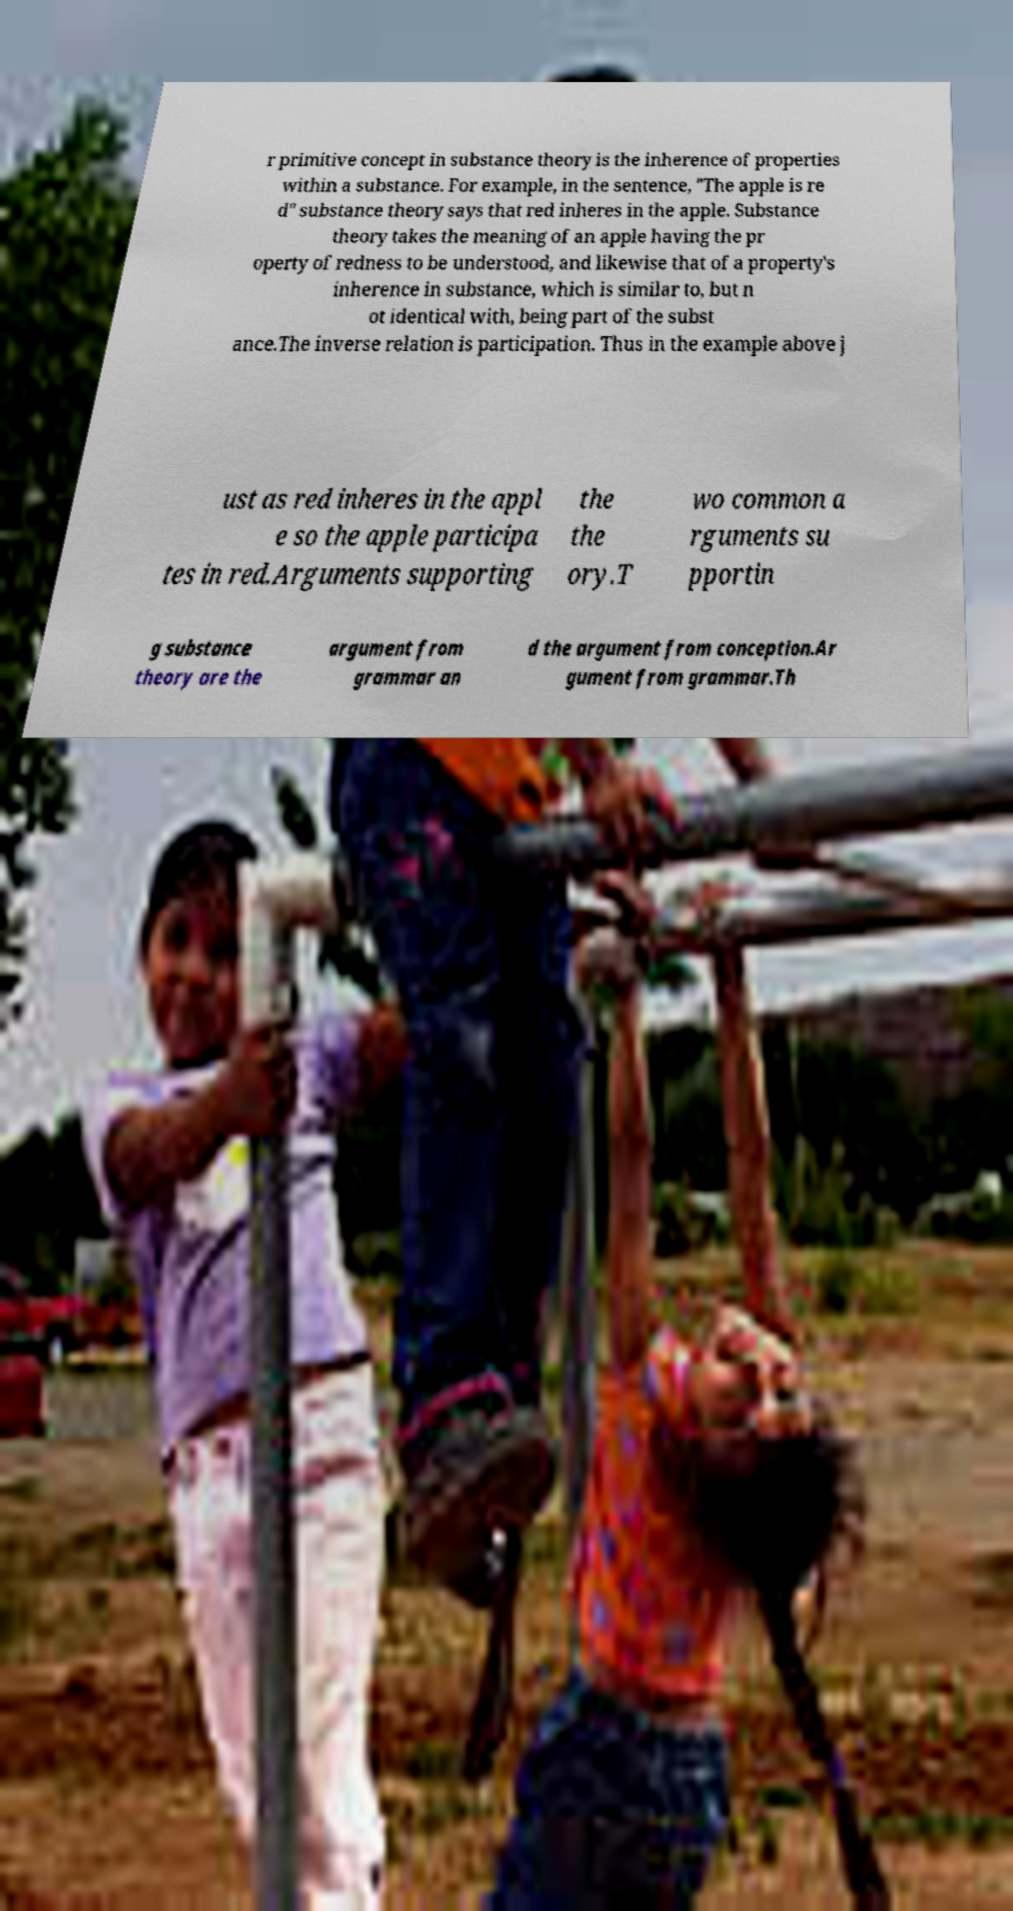Can you accurately transcribe the text from the provided image for me? r primitive concept in substance theory is the inherence of properties within a substance. For example, in the sentence, "The apple is re d" substance theory says that red inheres in the apple. Substance theory takes the meaning of an apple having the pr operty of redness to be understood, and likewise that of a property's inherence in substance, which is similar to, but n ot identical with, being part of the subst ance.The inverse relation is participation. Thus in the example above j ust as red inheres in the appl e so the apple participa tes in red.Arguments supporting the the ory.T wo common a rguments su pportin g substance theory are the argument from grammar an d the argument from conception.Ar gument from grammar.Th 